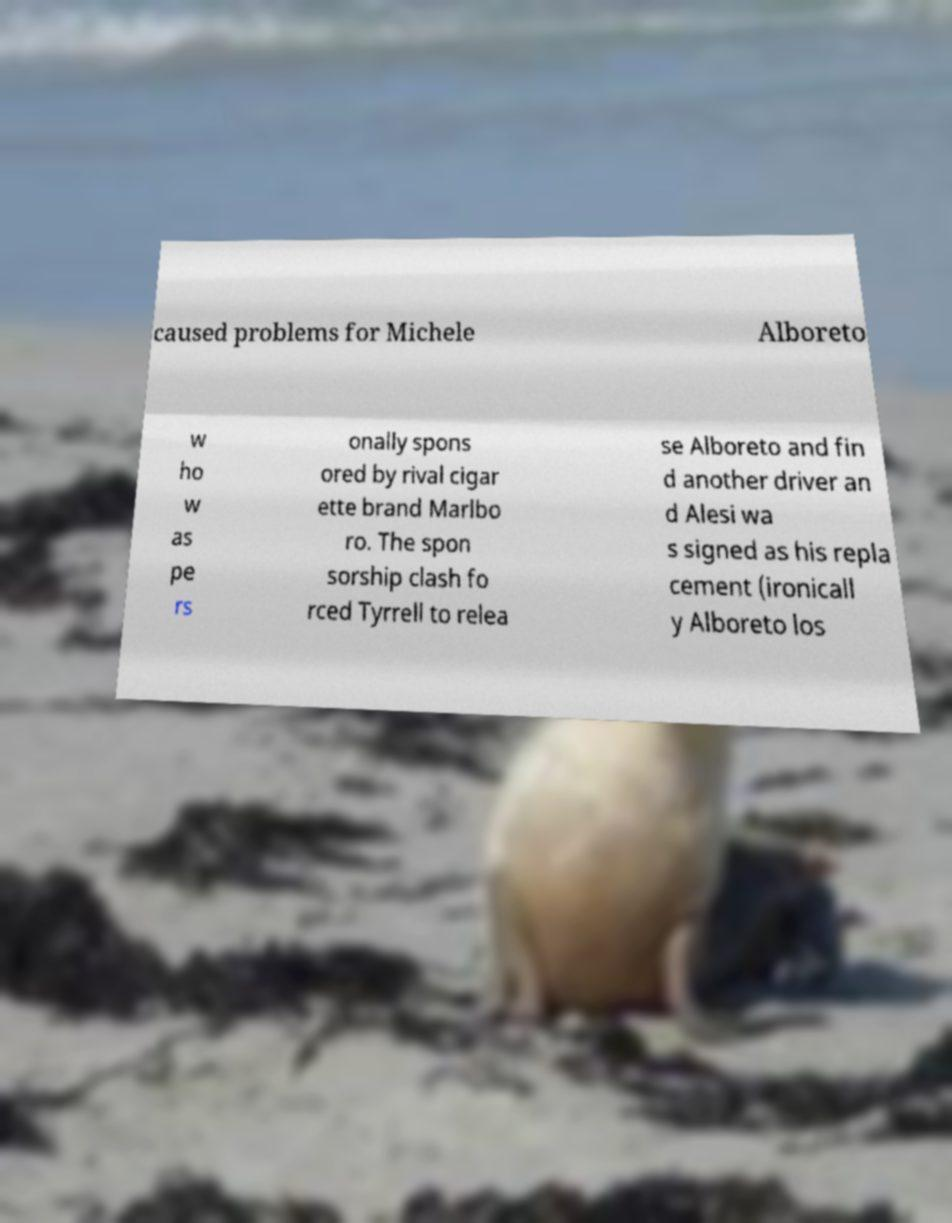Could you extract and type out the text from this image? caused problems for Michele Alboreto w ho w as pe rs onally spons ored by rival cigar ette brand Marlbo ro. The spon sorship clash fo rced Tyrrell to relea se Alboreto and fin d another driver an d Alesi wa s signed as his repla cement (ironicall y Alboreto los 